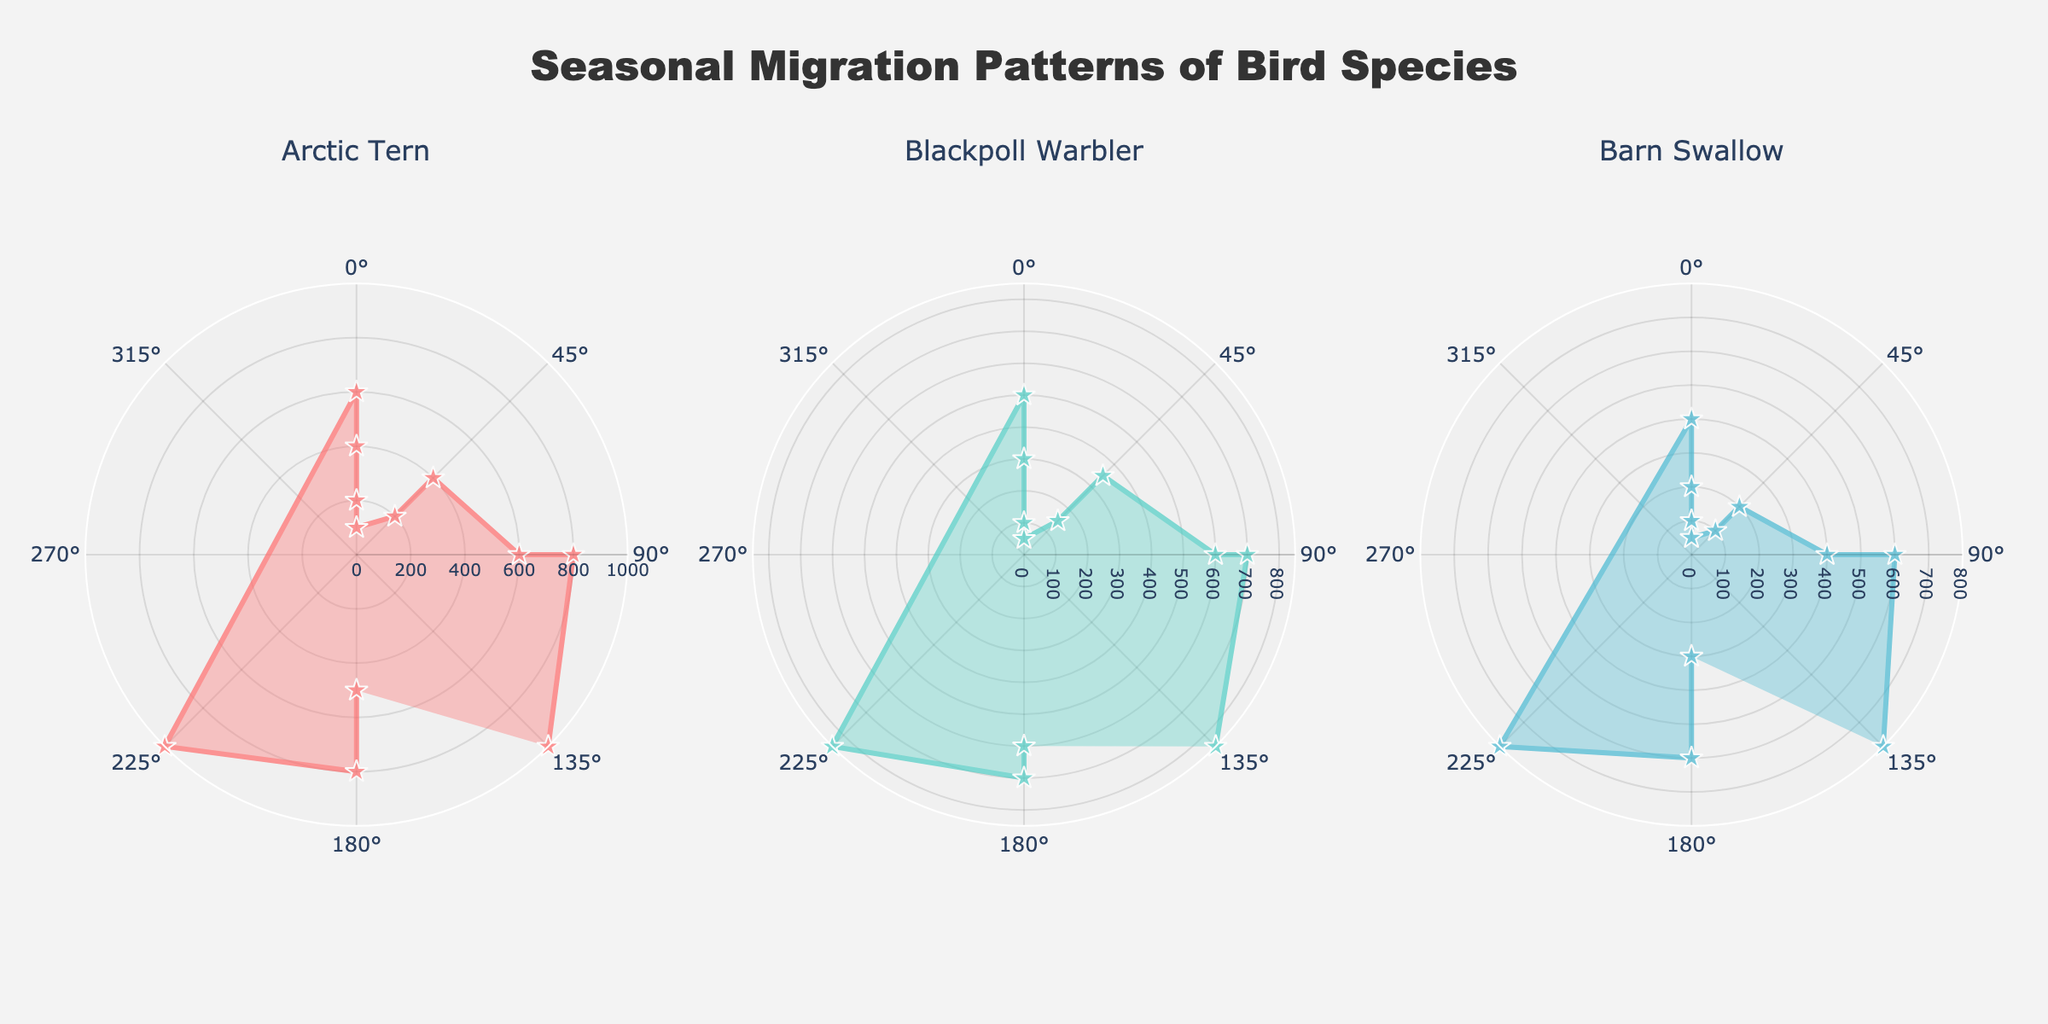Which bird species migrates the longest during December? Look at the migration distances shown in the chart for the three species in December. The Arctic Tern and Blackpoll Warbler each travel 1000 units, which is farther than the Barn Swallow's 800 units.
Answer: Arctic Tern and Blackpoll Warbler For the Arctic Tern, which month shows the shortest migration distance? Refer to the plot for the Arctic Tern and identify the month with the smallest radial distance. July has the shortest distance at 100 units.
Answer: July Compare the migration distances in March for all three species. Which species travels the furthest? Look at the distances for March in the plots for each species. The Arctic Tern's distance is 1000 units, the Blackpoll Warbler's is 850 units, and the Barn Swallow's distance is 800 units. The Arctic Tern has the longest migration distance.
Answer: Arctic Tern What is the average migration distance across all months for the Barn Swallow? Add the distances for each month for the Barn Swallow and divide by the number of months. (300 + 600 + 800 + 400 + 200 + 100 + 50 + 100 + 200 + 400 + 600 + 800)/12 = 350 units.
Answer: 350 units Which direction does the Blackpoll Warbler mostly migrate towards in February? Observe the direction indicated by the angle for the Blackpoll Warbler in February. The angle for February corresponds to 'S' or southward.
Answer: South What is the sum of migration distances in April for all three species? Add the distances for April for each species: 600 (Arctic Tern) + 500 (Blackpoll Warbler) + 400 (Barn Swallow) = 1500 units.
Answer: 1500 units In which month do the migration distances for the Arctic Tern, Blackpoll Warbler, and Barn Swallow all follow the same pattern of direction? Identify a month where the direction is the same for all three species. In January, all species migrate southward ('S').
Answer: January By how much does the migration distance increase for the Arctic Tern from January to February? Subtract the January distance from the February distance for the Arctic Tern. 800 - 500 = 300 units.
Answer: 300 units Which bird species has the smallest migration distance of any month, and what is that distance? Locate the smallest radial distance in the plots. The smallest distance is for the Barn Swallow in July with 50 units.
Answer: Barn Swallow, 50 units 